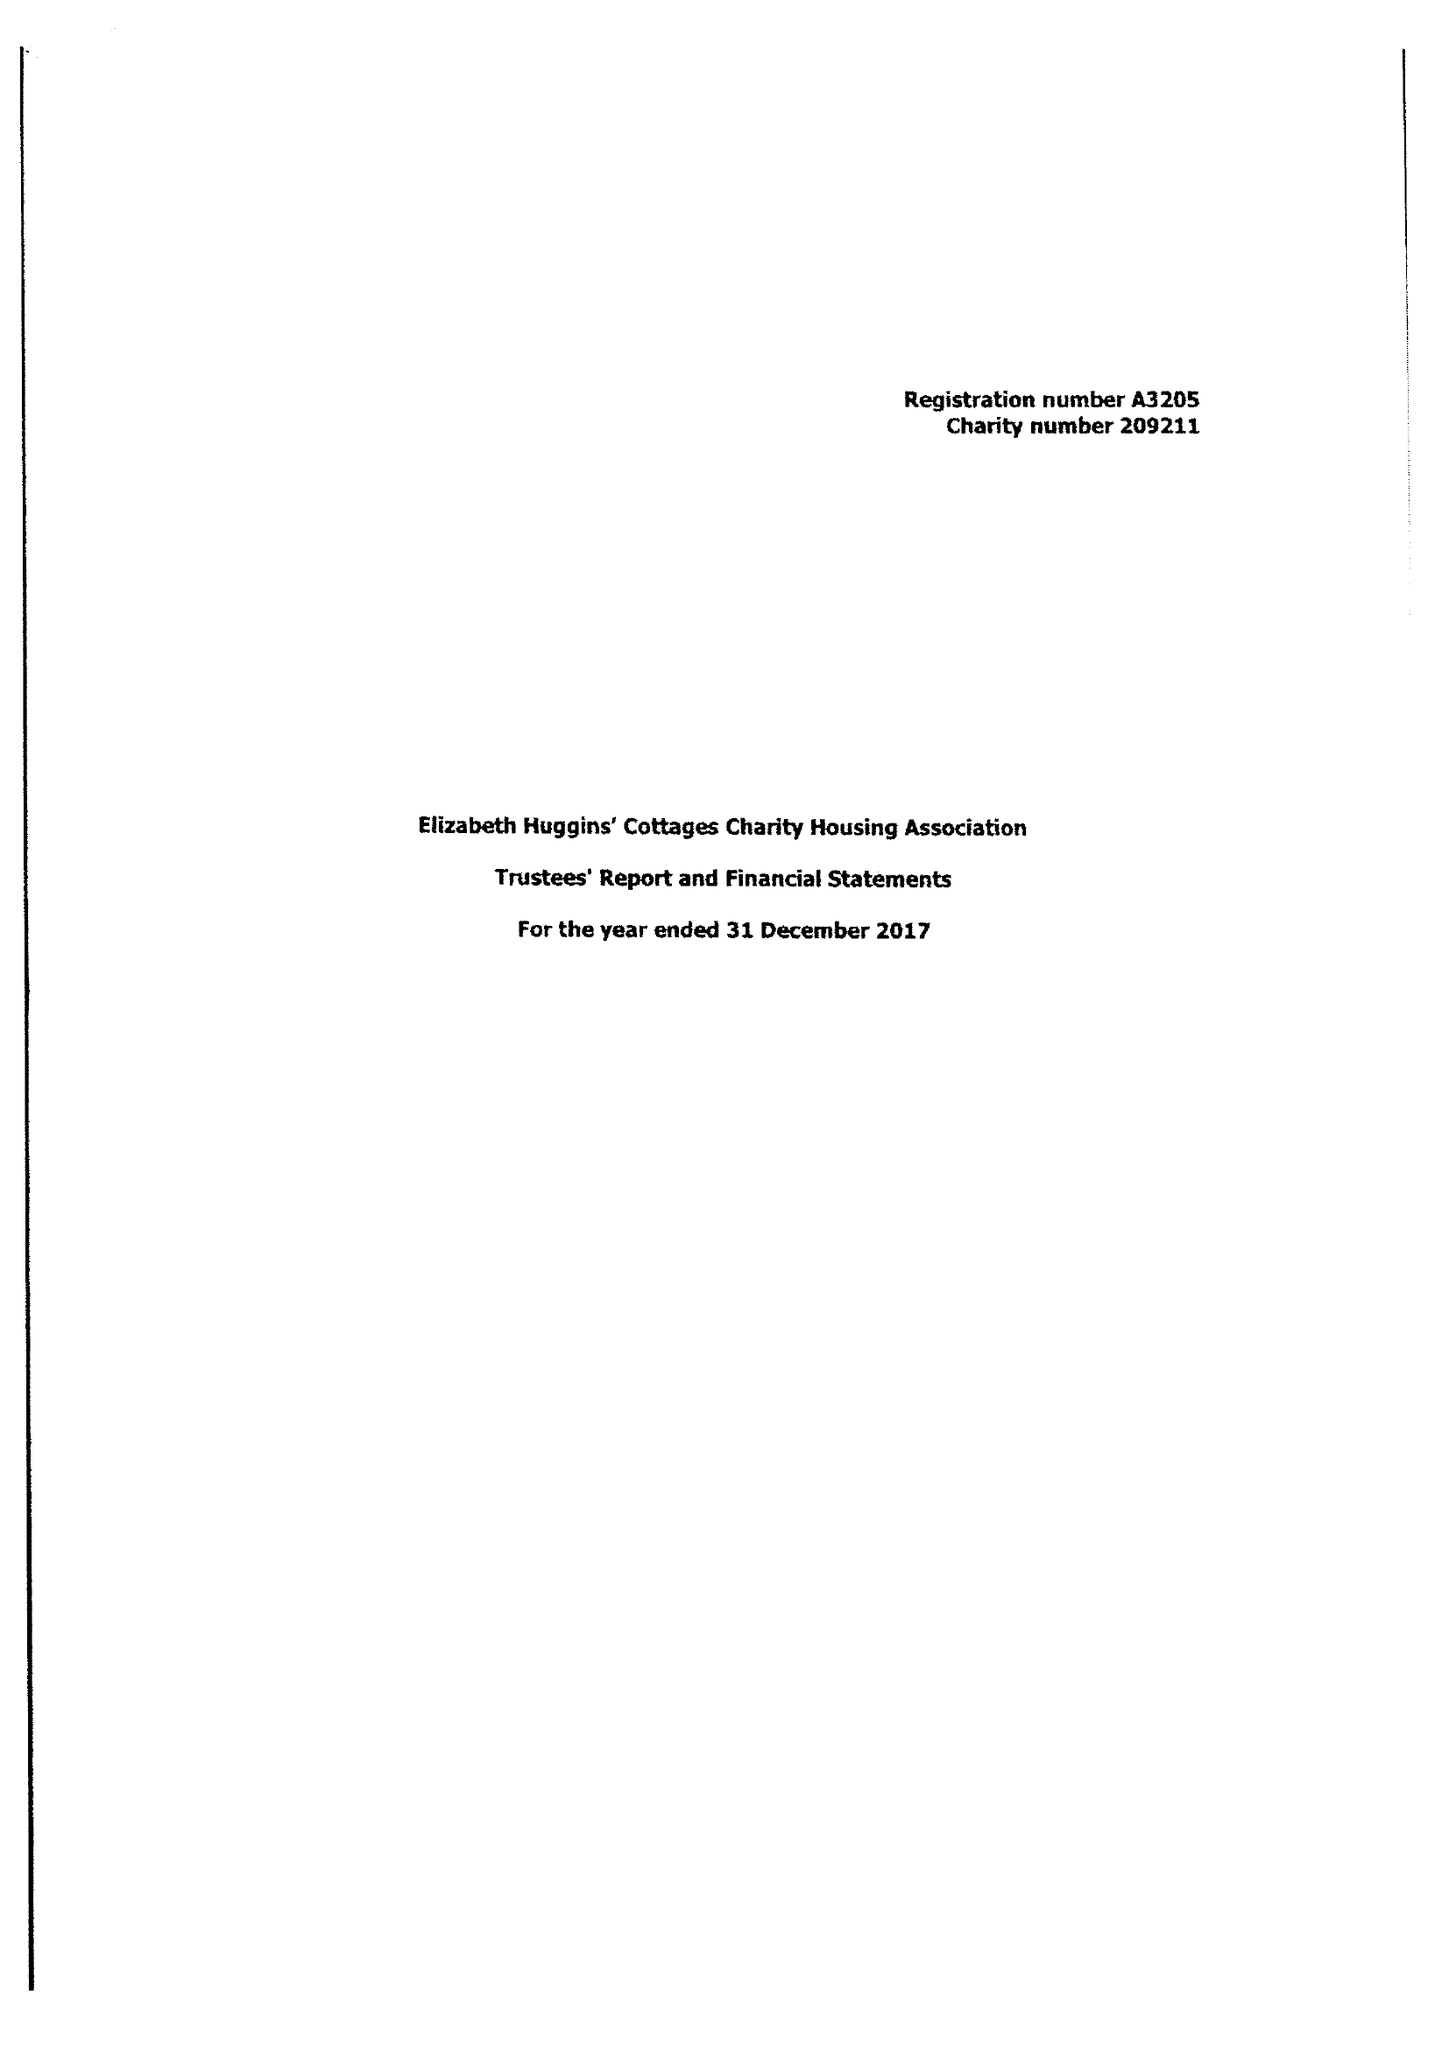What is the value for the report_date?
Answer the question using a single word or phrase. 2017-12-31 